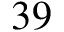<formula> <loc_0><loc_0><loc_500><loc_500>3 9</formula> 